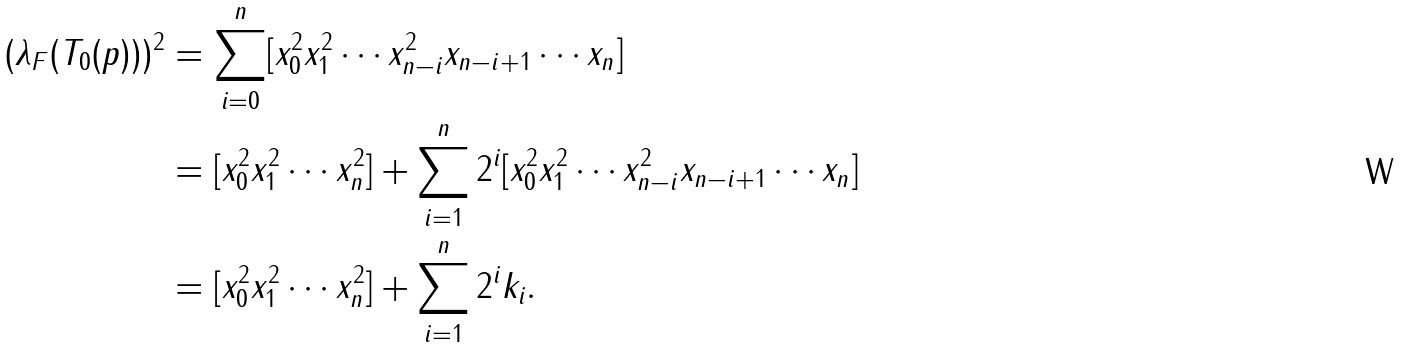Convert formula to latex. <formula><loc_0><loc_0><loc_500><loc_500>( \lambda _ { F } ( T _ { 0 } ( p ) ) ) ^ { 2 } & = \sum _ { i = 0 } ^ { n } [ x _ { 0 } ^ { 2 } x _ { 1 } ^ { 2 } \cdots x _ { n - i } ^ { 2 } x _ { n - i + 1 } \cdots x _ { n } ] \\ & = [ x _ { 0 } ^ { 2 } x _ { 1 } ^ { 2 } \cdots x _ { n } ^ { 2 } ] + \sum _ { i = 1 } ^ { n } 2 ^ { i } [ x _ { 0 } ^ { 2 } x _ { 1 } ^ { 2 } \cdots x _ { n - i } ^ { 2 } x _ { n - i + 1 } \cdots x _ { n } ] \\ & = [ x _ { 0 } ^ { 2 } x _ { 1 } ^ { 2 } \cdots x _ { n } ^ { 2 } ] + \sum _ { i = 1 } ^ { n } 2 ^ { i } k _ { i } .</formula> 